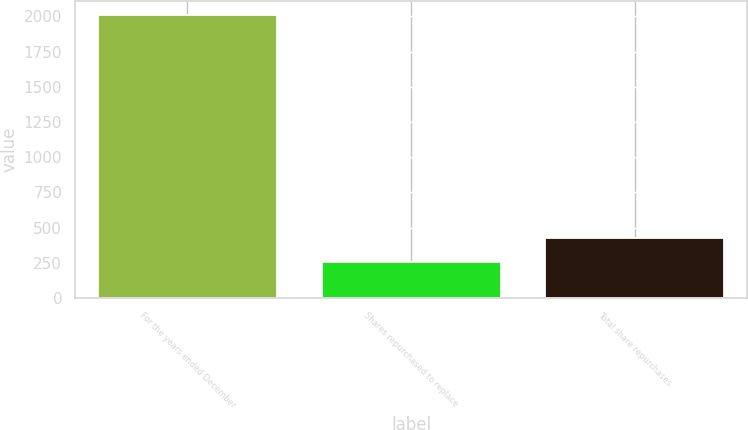Convert chart. <chart><loc_0><loc_0><loc_500><loc_500><bar_chart><fcel>For the years ended December<fcel>Shares repurchased to replace<fcel>Total share repurchases<nl><fcel>2009<fcel>252<fcel>427.7<nl></chart> 